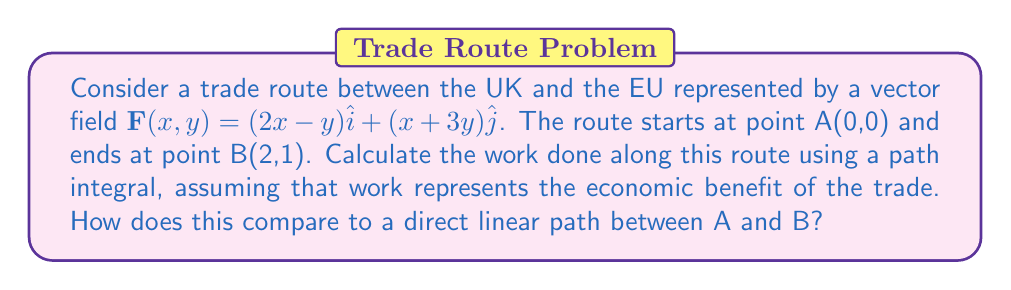Help me with this question. 1) To calculate the work done along the trade route, we need to evaluate the line integral of $\mathbf{F}$ along the path from A to B.

2) For a general path $\mathbf{r}(t) = (x(t), y(t))$, the line integral is given by:

   $$\int_C \mathbf{F} \cdot d\mathbf{r} = \int_a^b \mathbf{F}(\mathbf{r}(t)) \cdot \mathbf{r}'(t) dt$$

3) For a direct linear path from A(0,0) to B(2,1), we can parameterize the path as:
   
   $$\mathbf{r}(t) = (2t, t), \quad 0 \leq t \leq 1$$

4) Then, $\mathbf{r}'(t) = (2, 1)$

5) Substituting into the line integral:

   $$\int_0^1 [(2(2t)-t)\hat{i} + ((2t)+3t)\hat{j}] \cdot (2\hat{i} + \hat{j}) dt$$

6) Simplifying:

   $$\int_0^1 [(4t-t)(2) + (2t+3t)(1)] dt = \int_0^1 (8t-2t+2t+3t) dt = \int_0^1 11t dt$$

7) Evaluating the integral:

   $$[11t^2/2]_0^1 = 11/2 = 5.5$$

8) This result represents the economic benefit of the trade along the direct route.

9) To compare with other possible routes, we can use the Fundamental Theorem of Line Integrals. If $\mathbf{F}$ is a conservative field (which it is in this case), then the line integral is path-independent and equal to the difference in potential function values at the endpoints.

10) To find the potential function $\phi$, we integrate $\mathbf{F}$:

    $$\phi(x,y) = \int (2x-y) dx + f(y) = x^2 - xy + f(y)$$
    $$\frac{\partial \phi}{\partial y} = -x + f'(y) = x + 3y$$

    Therefore, $f'(y) = 4y$, so $f(y) = 2y^2 + C$

11) The potential function is:

    $$\phi(x,y) = x^2 - xy + 2y^2 + C$$

12) The work done along any path from A to B is:

    $$\phi(2,1) - \phi(0,0) = (4 - 2 + 2) - (0) = 4$$

13) This value (4) is less than the direct path calculation (5.5), indicating that the direct path is not optimal for maximizing economic benefit.
Answer: $4$ 